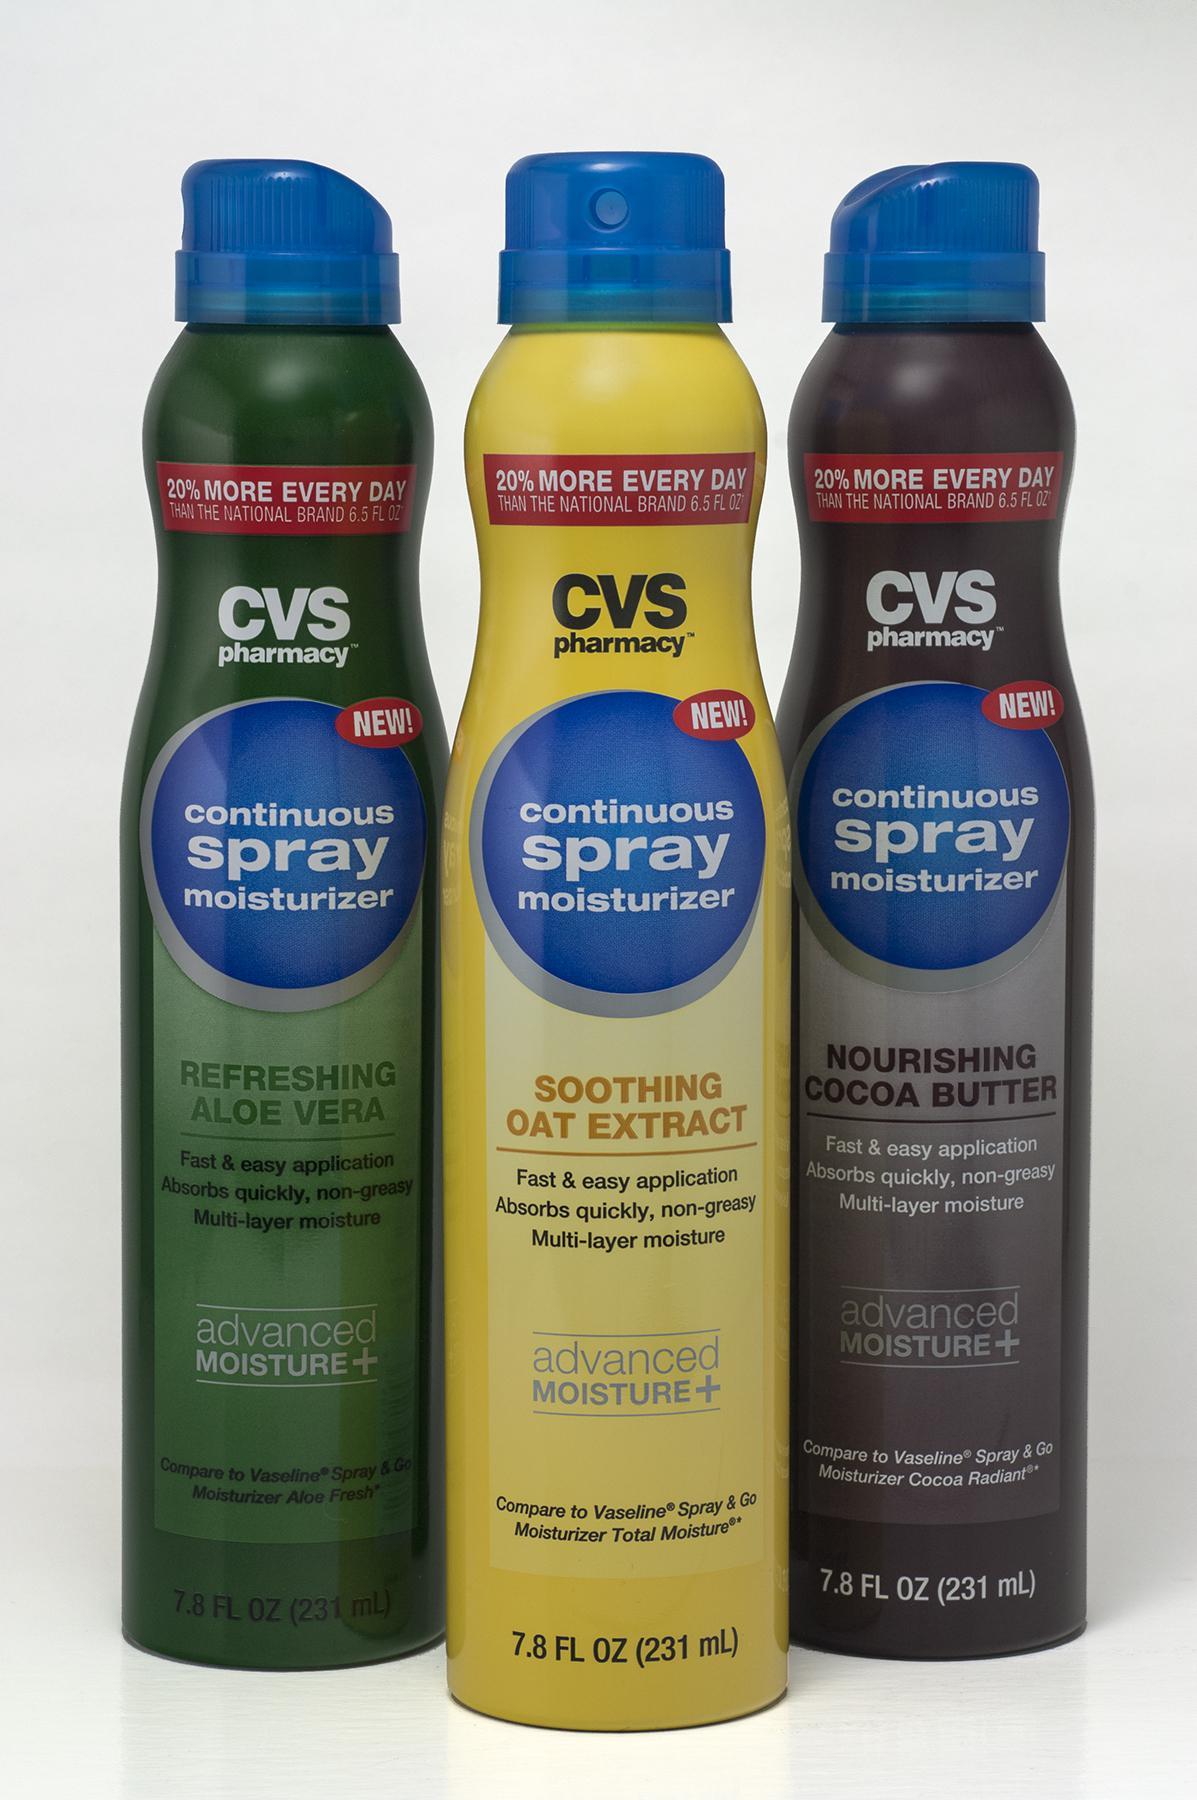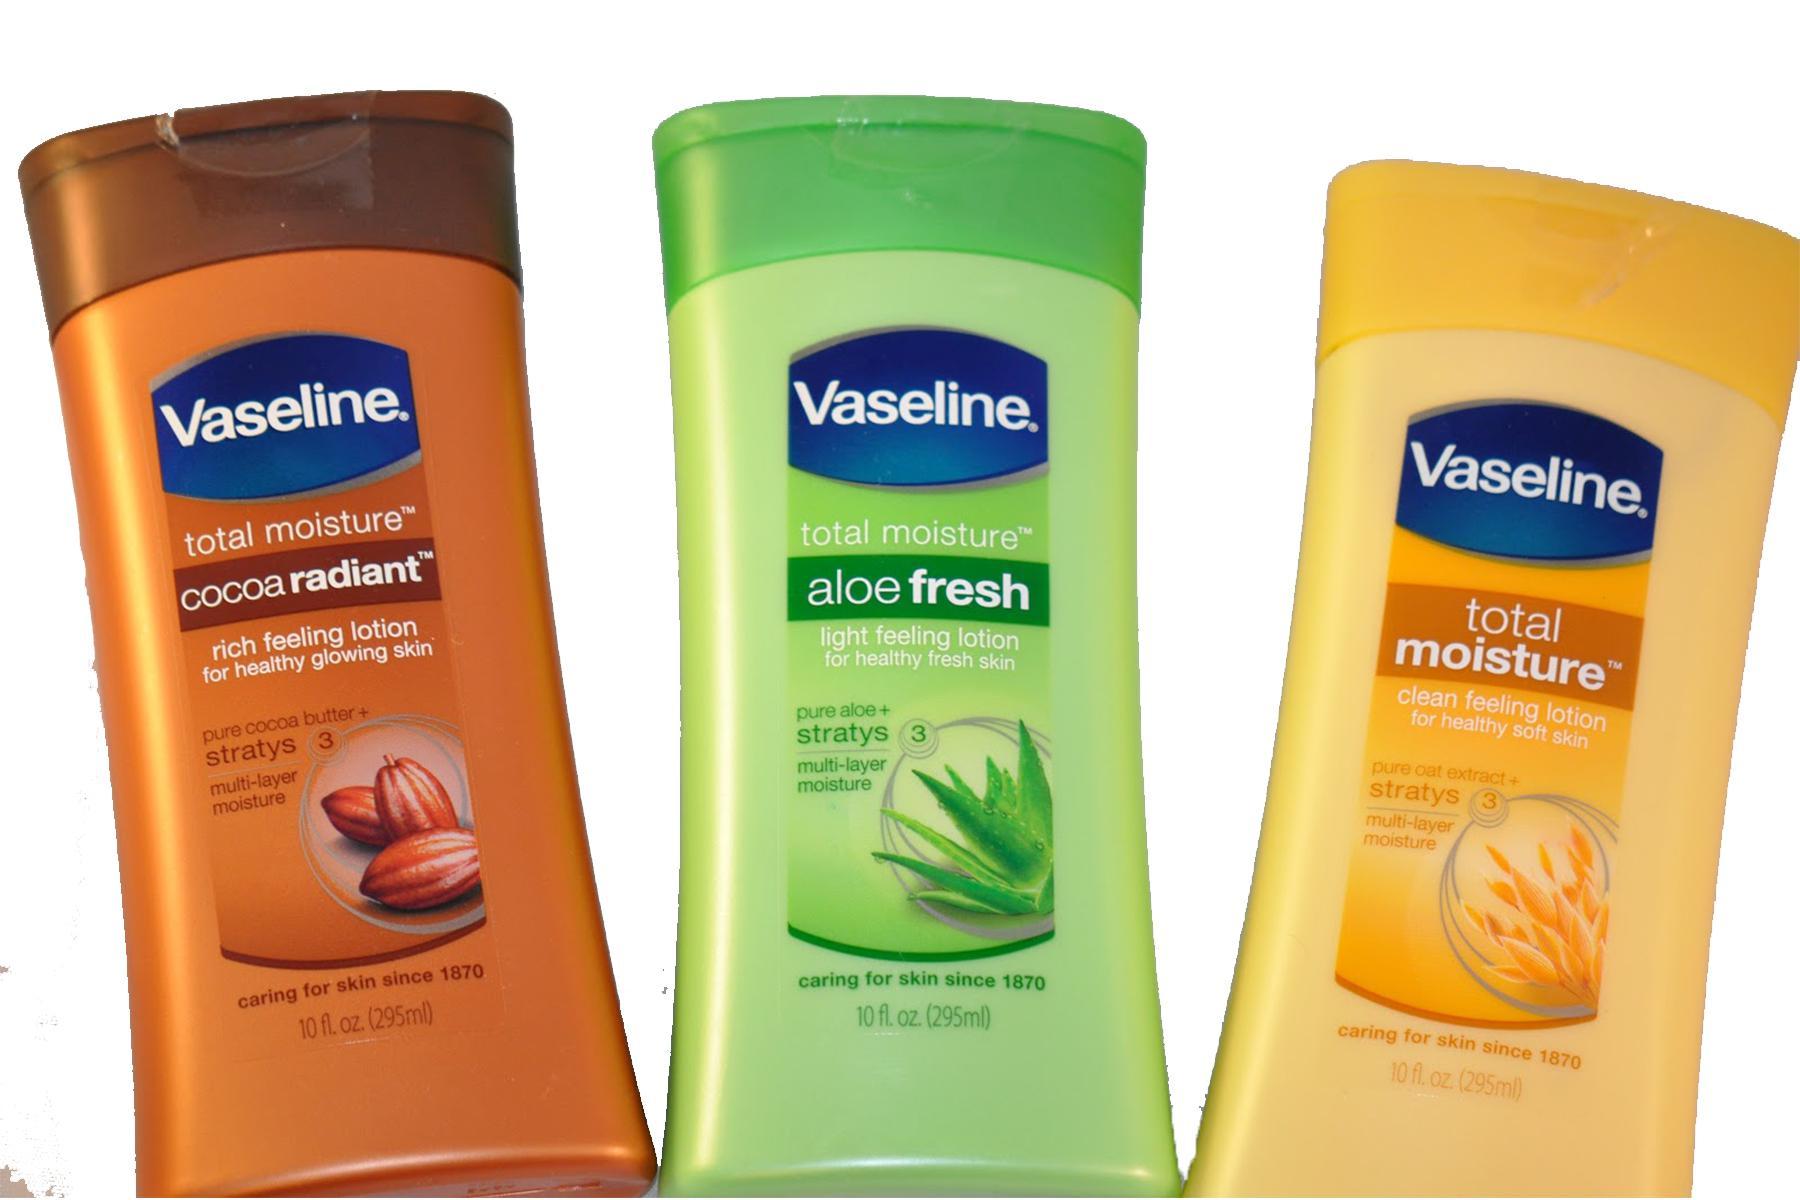The first image is the image on the left, the second image is the image on the right. For the images shown, is this caption "Each image shows at least three plastic bottles of a product in different colors." true? Answer yes or no. Yes. The first image is the image on the left, the second image is the image on the right. Analyze the images presented: Is the assertion "Each image contains at least three skincare products." valid? Answer yes or no. Yes. 